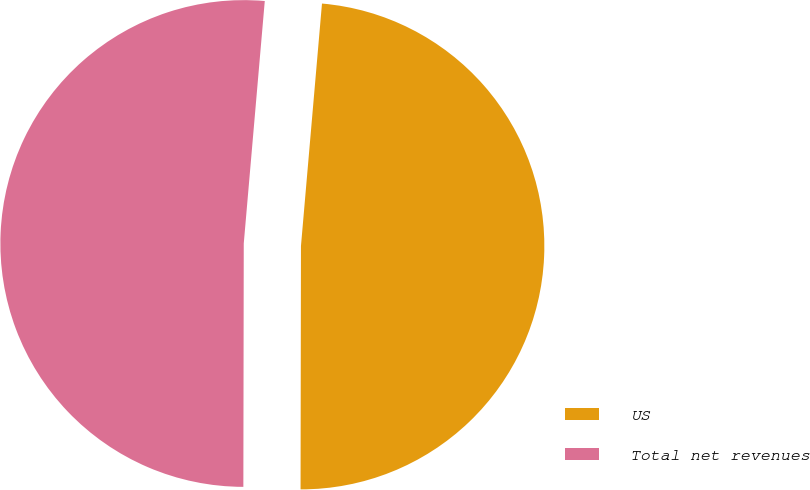<chart> <loc_0><loc_0><loc_500><loc_500><pie_chart><fcel>US<fcel>Total net revenues<nl><fcel>48.65%<fcel>51.35%<nl></chart> 